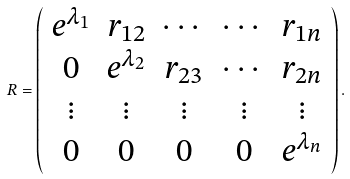Convert formula to latex. <formula><loc_0><loc_0><loc_500><loc_500>R = \left ( \begin{array} { c c c c c } e ^ { \lambda _ { 1 } } & r _ { 1 2 } & \cdots & \cdots & r _ { 1 n } \\ 0 & e ^ { \lambda _ { 2 } } & r _ { 2 3 } & \cdots & r _ { 2 n } \\ \vdots & \vdots & \vdots & \vdots & \vdots \\ 0 & 0 & 0 & 0 & e ^ { \lambda _ { n } } \end{array} \right ) .</formula> 